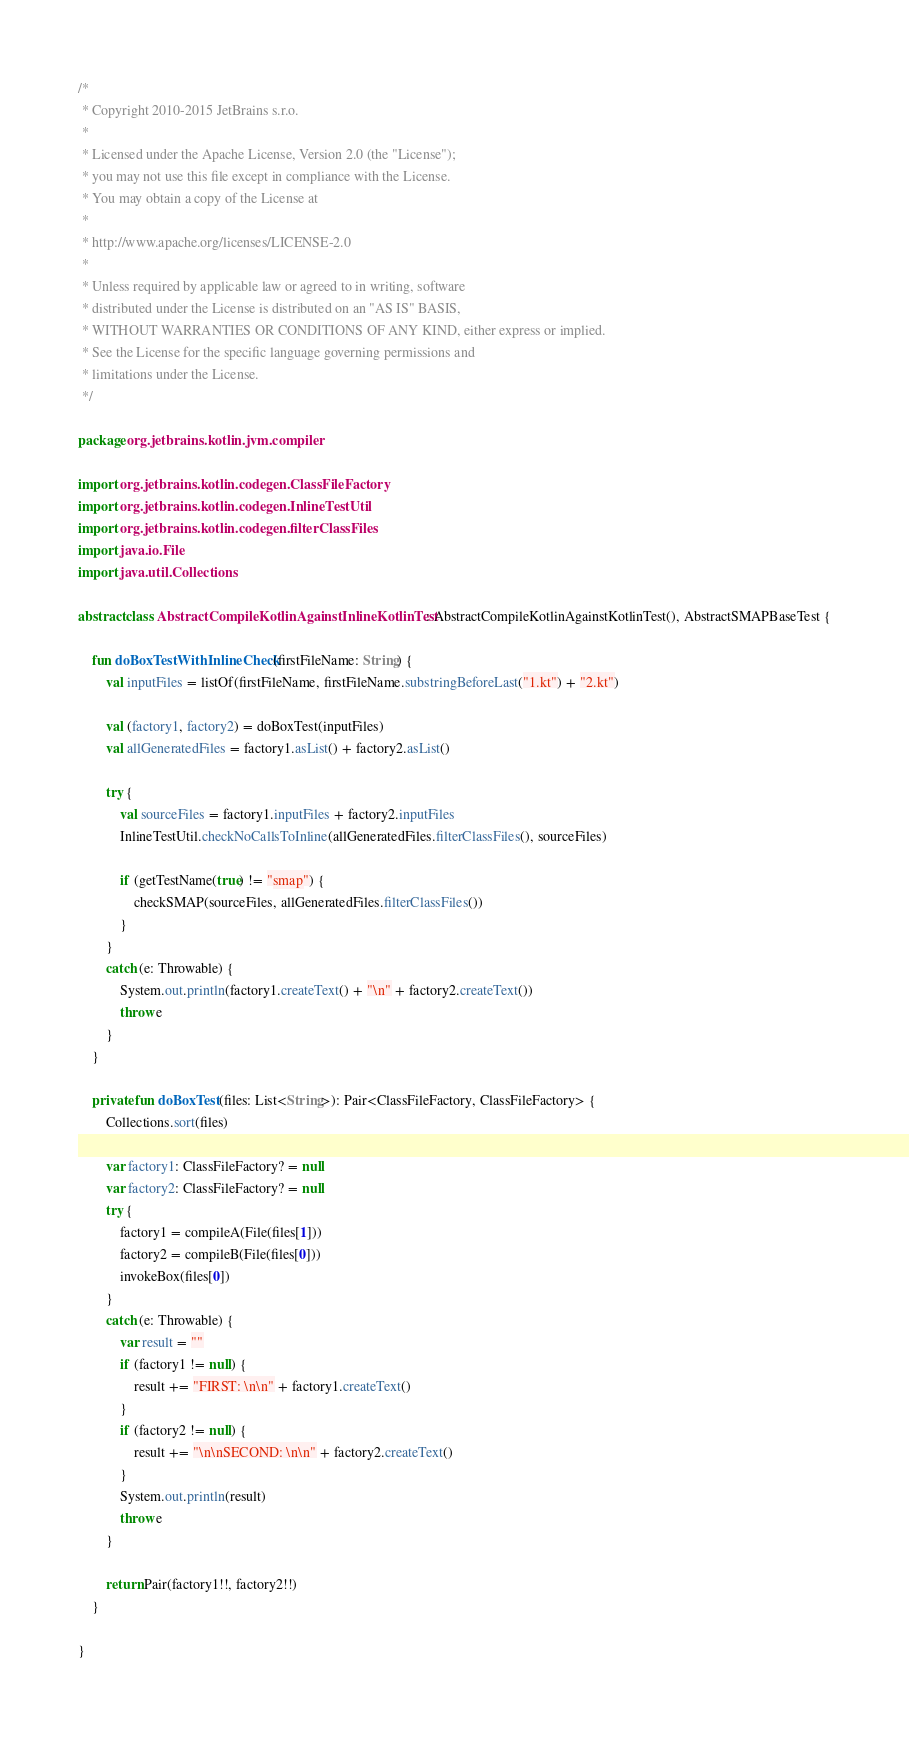Convert code to text. <code><loc_0><loc_0><loc_500><loc_500><_Kotlin_>/*
 * Copyright 2010-2015 JetBrains s.r.o.
 *
 * Licensed under the Apache License, Version 2.0 (the "License");
 * you may not use this file except in compliance with the License.
 * You may obtain a copy of the License at
 *
 * http://www.apache.org/licenses/LICENSE-2.0
 *
 * Unless required by applicable law or agreed to in writing, software
 * distributed under the License is distributed on an "AS IS" BASIS,
 * WITHOUT WARRANTIES OR CONDITIONS OF ANY KIND, either express or implied.
 * See the License for the specific language governing permissions and
 * limitations under the License.
 */

package org.jetbrains.kotlin.jvm.compiler

import org.jetbrains.kotlin.codegen.ClassFileFactory
import org.jetbrains.kotlin.codegen.InlineTestUtil
import org.jetbrains.kotlin.codegen.filterClassFiles
import java.io.File
import java.util.Collections

abstract class AbstractCompileKotlinAgainstInlineKotlinTest : AbstractCompileKotlinAgainstKotlinTest(), AbstractSMAPBaseTest {

    fun doBoxTestWithInlineCheck(firstFileName: String) {
        val inputFiles = listOf(firstFileName, firstFileName.substringBeforeLast("1.kt") + "2.kt")

        val (factory1, factory2) = doBoxTest(inputFiles)
        val allGeneratedFiles = factory1.asList() + factory2.asList()

        try {
            val sourceFiles = factory1.inputFiles + factory2.inputFiles
            InlineTestUtil.checkNoCallsToInline(allGeneratedFiles.filterClassFiles(), sourceFiles)

            if (getTestName(true) != "smap") {
                checkSMAP(sourceFiles, allGeneratedFiles.filterClassFiles())
            }
        }
        catch (e: Throwable) {
            System.out.println(factory1.createText() + "\n" + factory2.createText())
            throw e
        }
    }

    private fun doBoxTest(files: List<String>): Pair<ClassFileFactory, ClassFileFactory> {
        Collections.sort(files)

        var factory1: ClassFileFactory? = null
        var factory2: ClassFileFactory? = null
        try {
            factory1 = compileA(File(files[1]))
            factory2 = compileB(File(files[0]))
            invokeBox(files[0])
        }
        catch (e: Throwable) {
            var result = ""
            if (factory1 != null) {
                result += "FIRST: \n\n" + factory1.createText()
            }
            if (factory2 != null) {
                result += "\n\nSECOND: \n\n" + factory2.createText()
            }
            System.out.println(result)
            throw e
        }

        return Pair(factory1!!, factory2!!)
    }

}
</code> 